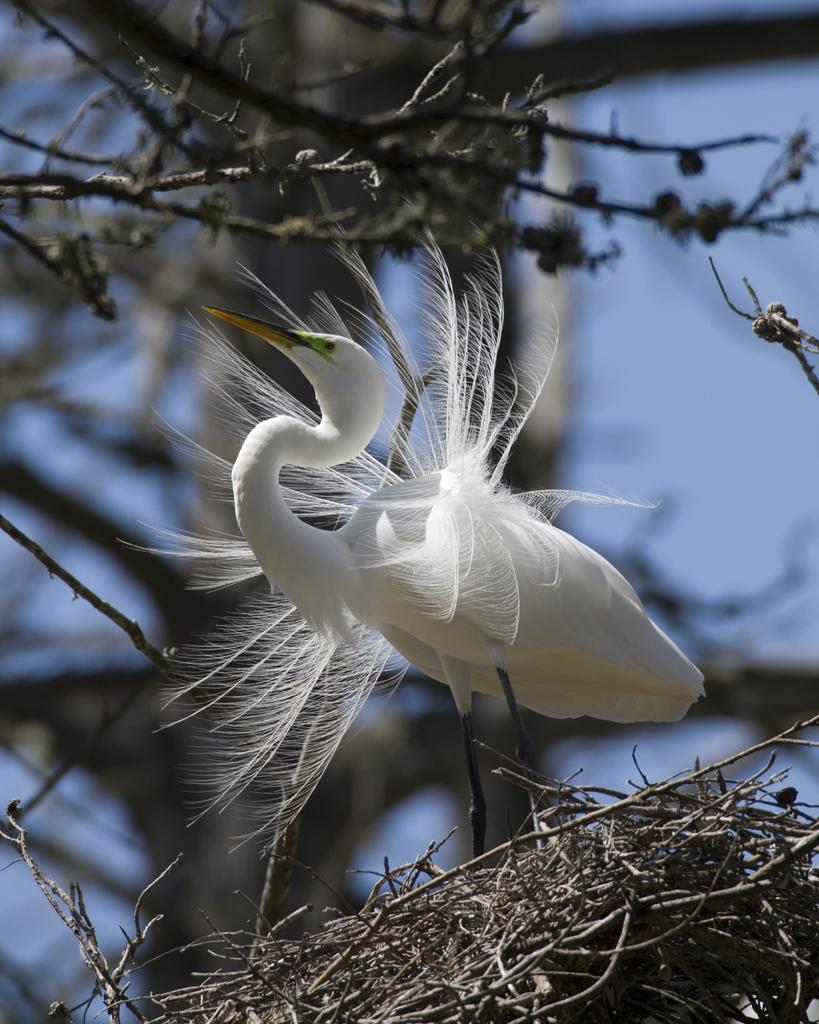What type of animal can be seen in the image? There is a bird in the image. What is the color of the bird? The bird is white in color. Where is the bird located in the image? The bird is on a nest. What can be seen in the background of the image? There are branches of a tree visible in the image. What type of shade does the hen prefer in the image? There is no hen present in the image, and therefore no shade preference can be determined. 